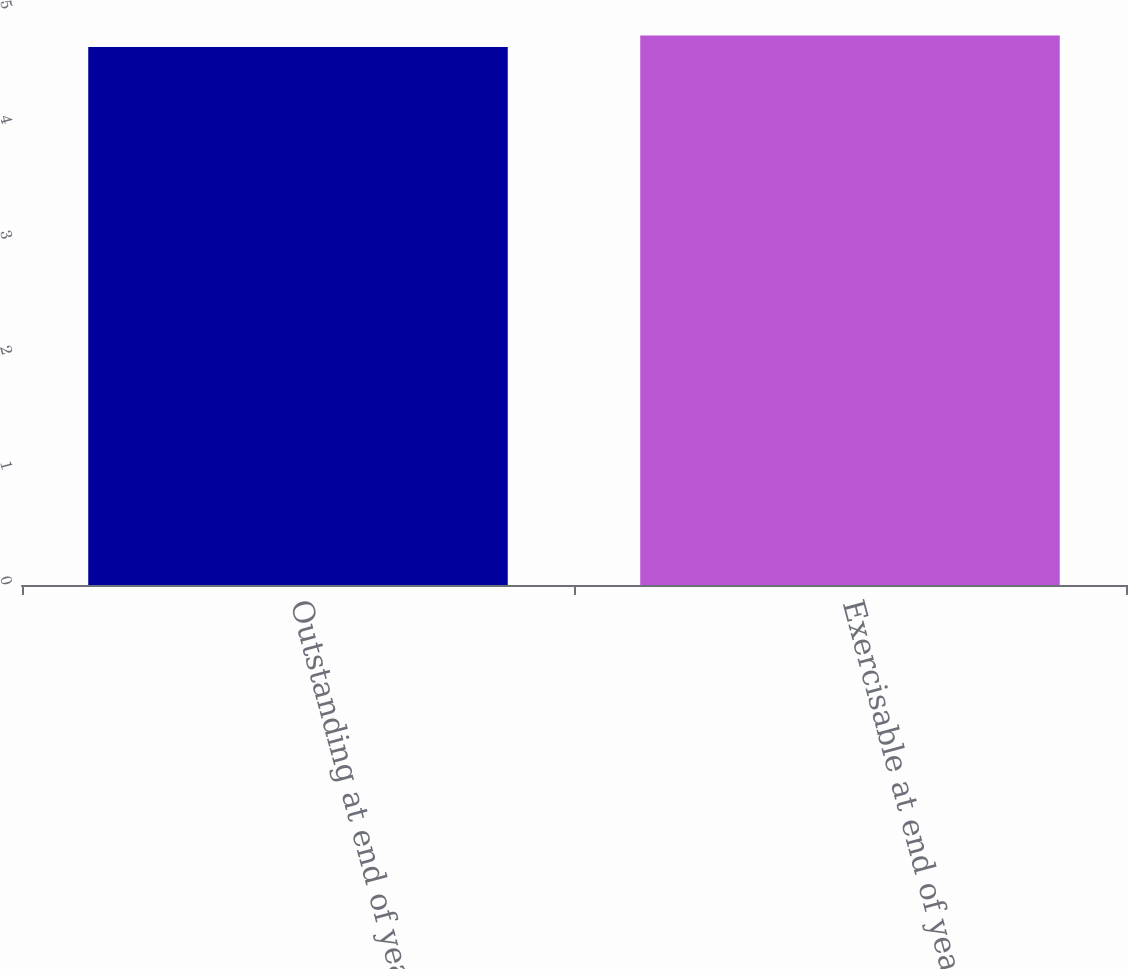Convert chart to OTSL. <chart><loc_0><loc_0><loc_500><loc_500><bar_chart><fcel>Outstanding at end of year<fcel>Exercisable at end of year<nl><fcel>4.67<fcel>4.77<nl></chart> 